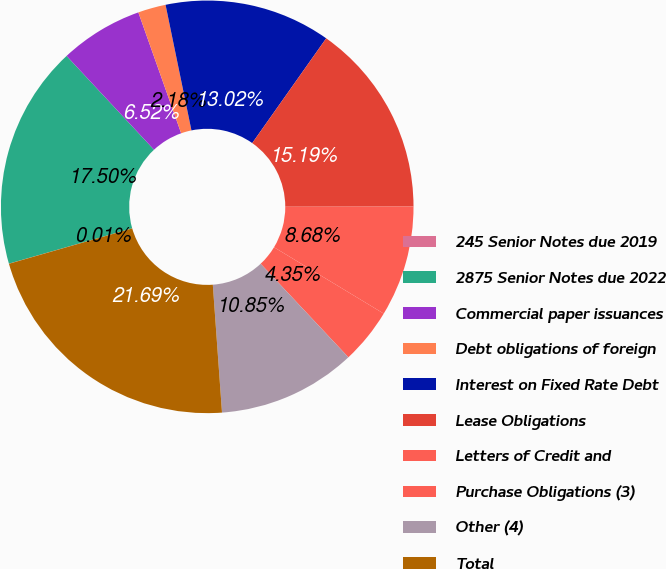<chart> <loc_0><loc_0><loc_500><loc_500><pie_chart><fcel>245 Senior Notes due 2019<fcel>2875 Senior Notes due 2022<fcel>Commercial paper issuances<fcel>Debt obligations of foreign<fcel>Interest on Fixed Rate Debt<fcel>Lease Obligations<fcel>Letters of Credit and<fcel>Purchase Obligations (3)<fcel>Other (4)<fcel>Total<nl><fcel>0.01%<fcel>17.5%<fcel>6.52%<fcel>2.18%<fcel>13.02%<fcel>15.19%<fcel>8.68%<fcel>4.35%<fcel>10.85%<fcel>21.69%<nl></chart> 